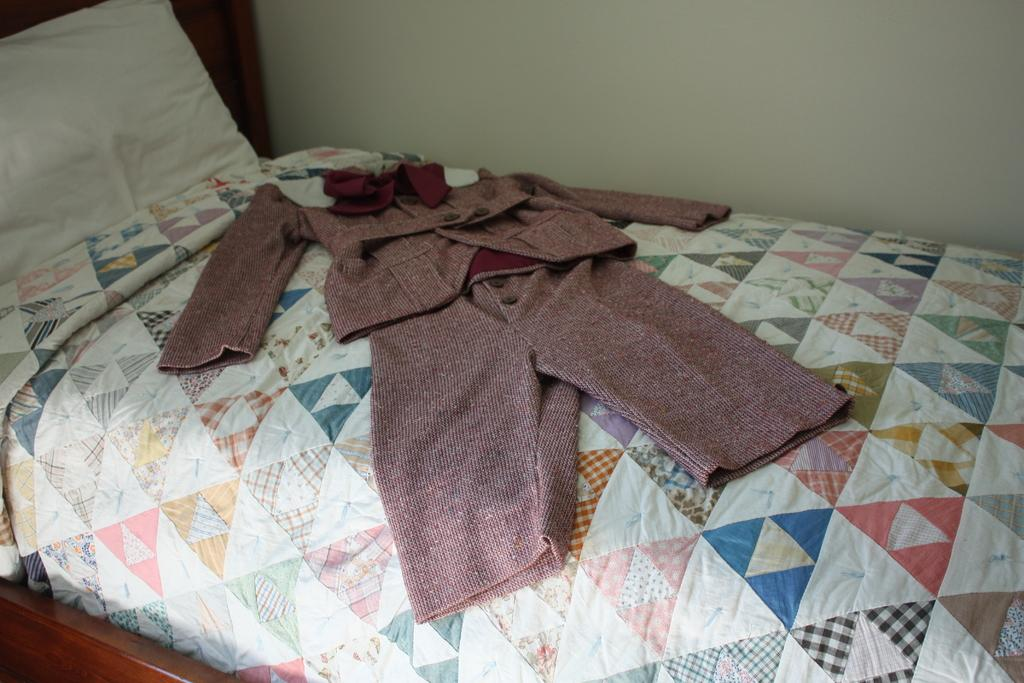What piece of furniture is present in the image? There is a bed in the image. What is placed on the bed? There is a pillow on the bed, and there are clothes on the bed as well. What can be seen in the background of the image? There is a wall visible in the background of the image. What type of music can be heard playing in the background of the image? There is no music present in the image, as it is a still photograph. 